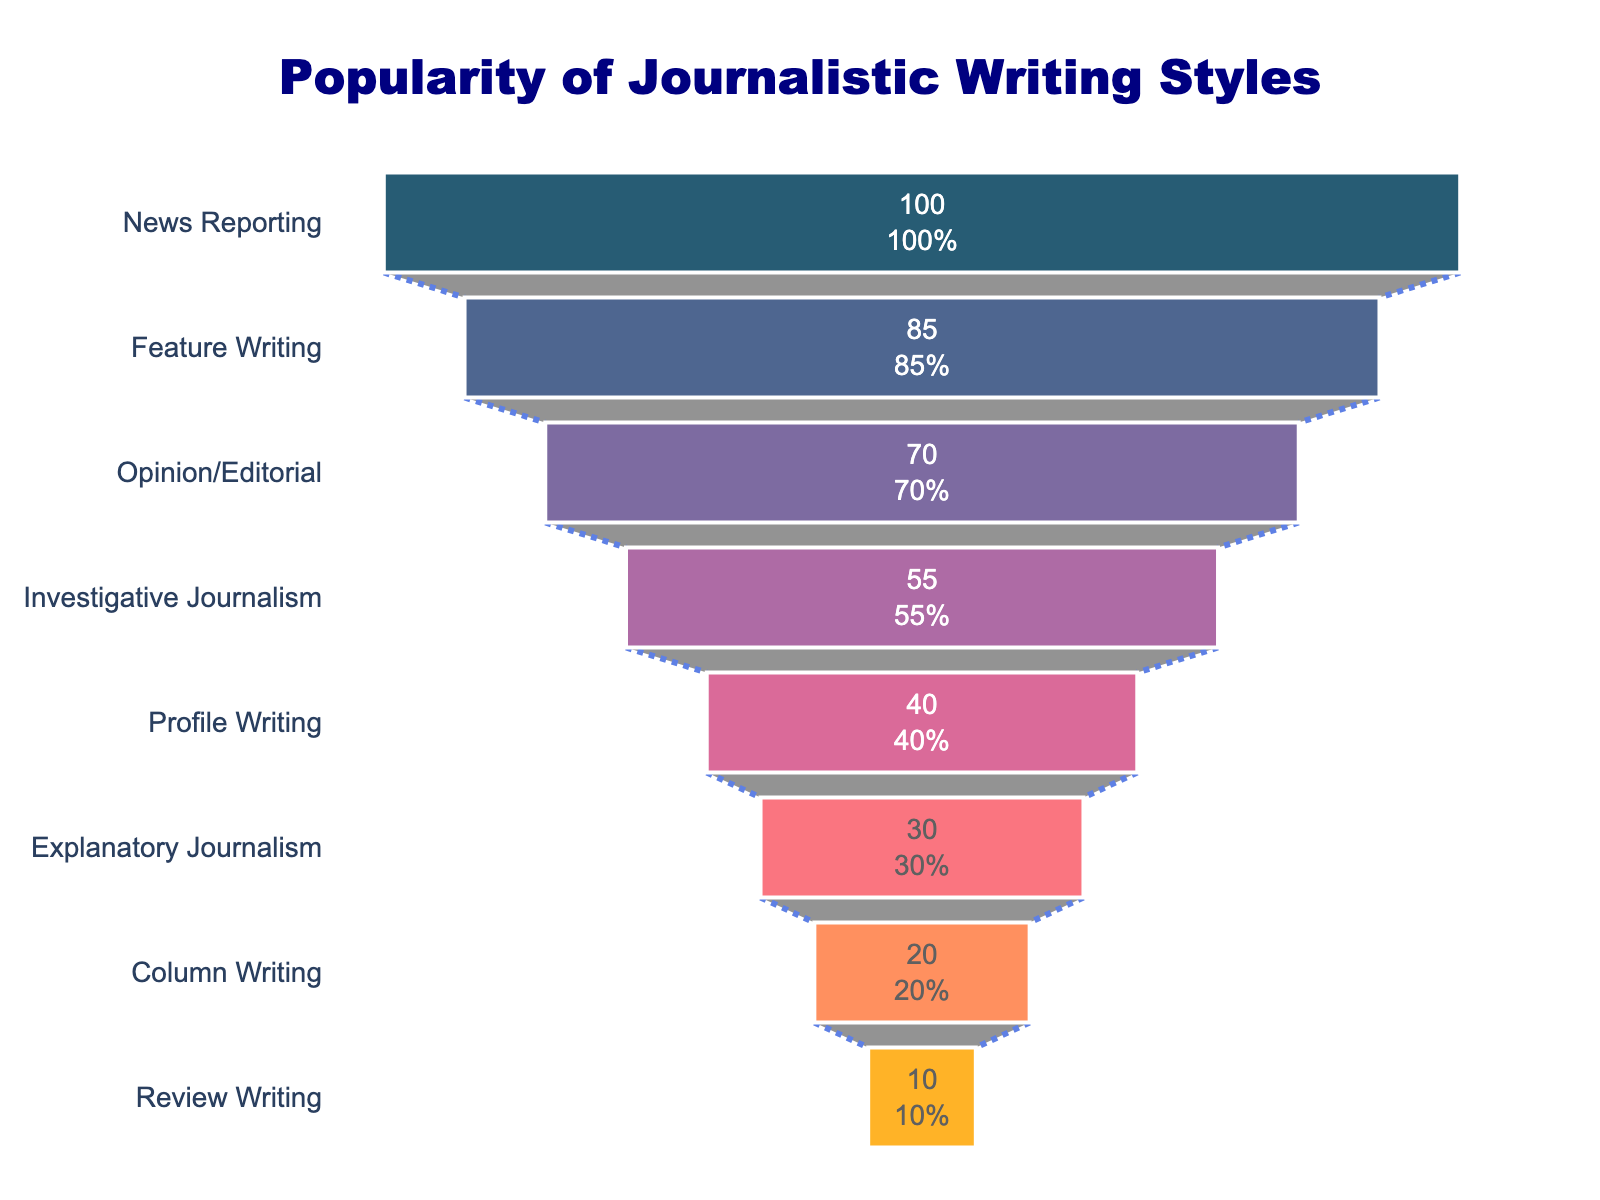What's the title of the figure? The title is usually placed at the top of the figure and describes what the chart represents. In this case, the large and bold text should be easily noticeable.
Answer: Popularity of Journalistic Writing Styles What writing style is at the top of the funnel chart? The top of the funnel chart will have the first category listed. It is also the widest part of the funnel.
Answer: News Reporting What is the percentage for Opinion/Editorial writing? Find "Opinion/Editorial" on the vertical axis and check its corresponding percentage displayed inside the funnel section.
Answer: 70% Which writing style is the least popular according to the chart? The bottom section of the funnel chart represents the least popular writing style.
Answer: Review Writing How much more popular is Feature Writing compared to Review Writing? Subtract the percentage of Review Writing from the percentage of Feature Writing. Feature Writing: 85%, Review Writing: 10%. 85 - 10 = 75
Answer: 75% If the total number of writings surveyed is 1000, how many writings fall under Investigative Journalism? Multiply the percentage of Investigative Journalism by the total number (1000). Investigative Journalism: 55%. 1000 * 0.55 = 550
Answer: 550 Which writing style is more popular: Column Writing or Explanatory Journalism, and by how much? Find the percentage of both Column Writing and Explanatory Journalism, then subtract the smaller percentage from the larger. Column Writing: 20%, Explanatory Journalism: 30%. 30 - 20 = 10
Answer: Explanatory Journalism, by 10% Arrange the writing styles in descending order of popularity. List the writing styles from the widest to the narrowest section on the funnel chart from top to bottom.
Answer: News Reporting, Feature Writing, Opinion/Editorial, Investigative Journalism, Profile Writing, Explanatory Journalism, Column Writing, Review Writing What is the combined percentage of News Reporting, Feature Writing, and Opinion/Editorial? Add the percentages of the three mentioned writing styles. News Reporting: 100%, Feature Writing: 85%, Opinion/Editorial: 70%. 100 + 85 + 70 = 255
Answer: 255 By what percentage is Profile Writing more popular than Column Writing? Subtract the percentage of Column Writing from Profile Writing. Profile Writing: 40%, Column Writing: 20%. 40 - 20 = 20
Answer: 20% 